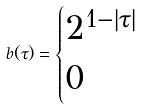<formula> <loc_0><loc_0><loc_500><loc_500>b ( \tau ) = \begin{cases} 2 ^ { 1 - | \tau | } & \\ 0 & \end{cases}</formula> 